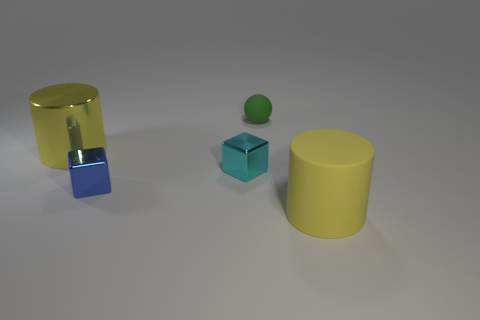Are there any rubber cylinders that have the same color as the rubber sphere?
Make the answer very short. No. Are there any other big metallic things of the same shape as the blue shiny object?
Your answer should be compact. No. There is a object that is behind the cyan thing and to the right of the big yellow metal thing; what is its shape?
Offer a very short reply. Sphere. What number of blue blocks have the same material as the small cyan block?
Your answer should be very brief. 1. Are there fewer small balls that are in front of the blue metallic object than blue shiny cubes?
Give a very brief answer. Yes. Are there any big cylinders right of the ball on the right side of the small cyan block?
Give a very brief answer. Yes. Are there any other things that have the same shape as the tiny blue metallic object?
Make the answer very short. Yes. Is the size of the cyan shiny object the same as the matte sphere?
Your response must be concise. Yes. The large yellow thing that is in front of the big thing that is to the left of the big yellow object that is in front of the yellow shiny thing is made of what material?
Make the answer very short. Rubber. Are there the same number of large rubber cylinders that are in front of the large shiny thing and matte cylinders?
Keep it short and to the point. Yes. 